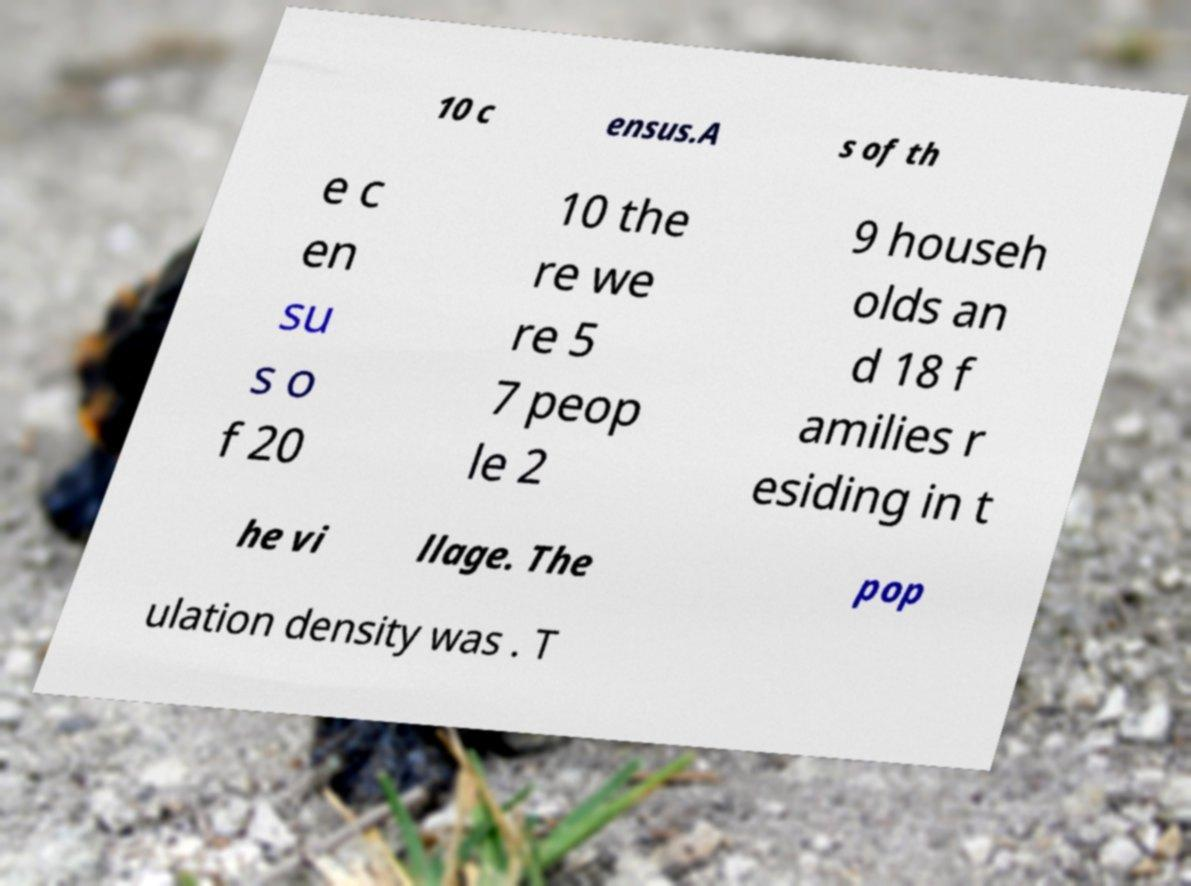Please read and relay the text visible in this image. What does it say? 10 c ensus.A s of th e c en su s o f 20 10 the re we re 5 7 peop le 2 9 househ olds an d 18 f amilies r esiding in t he vi llage. The pop ulation density was . T 